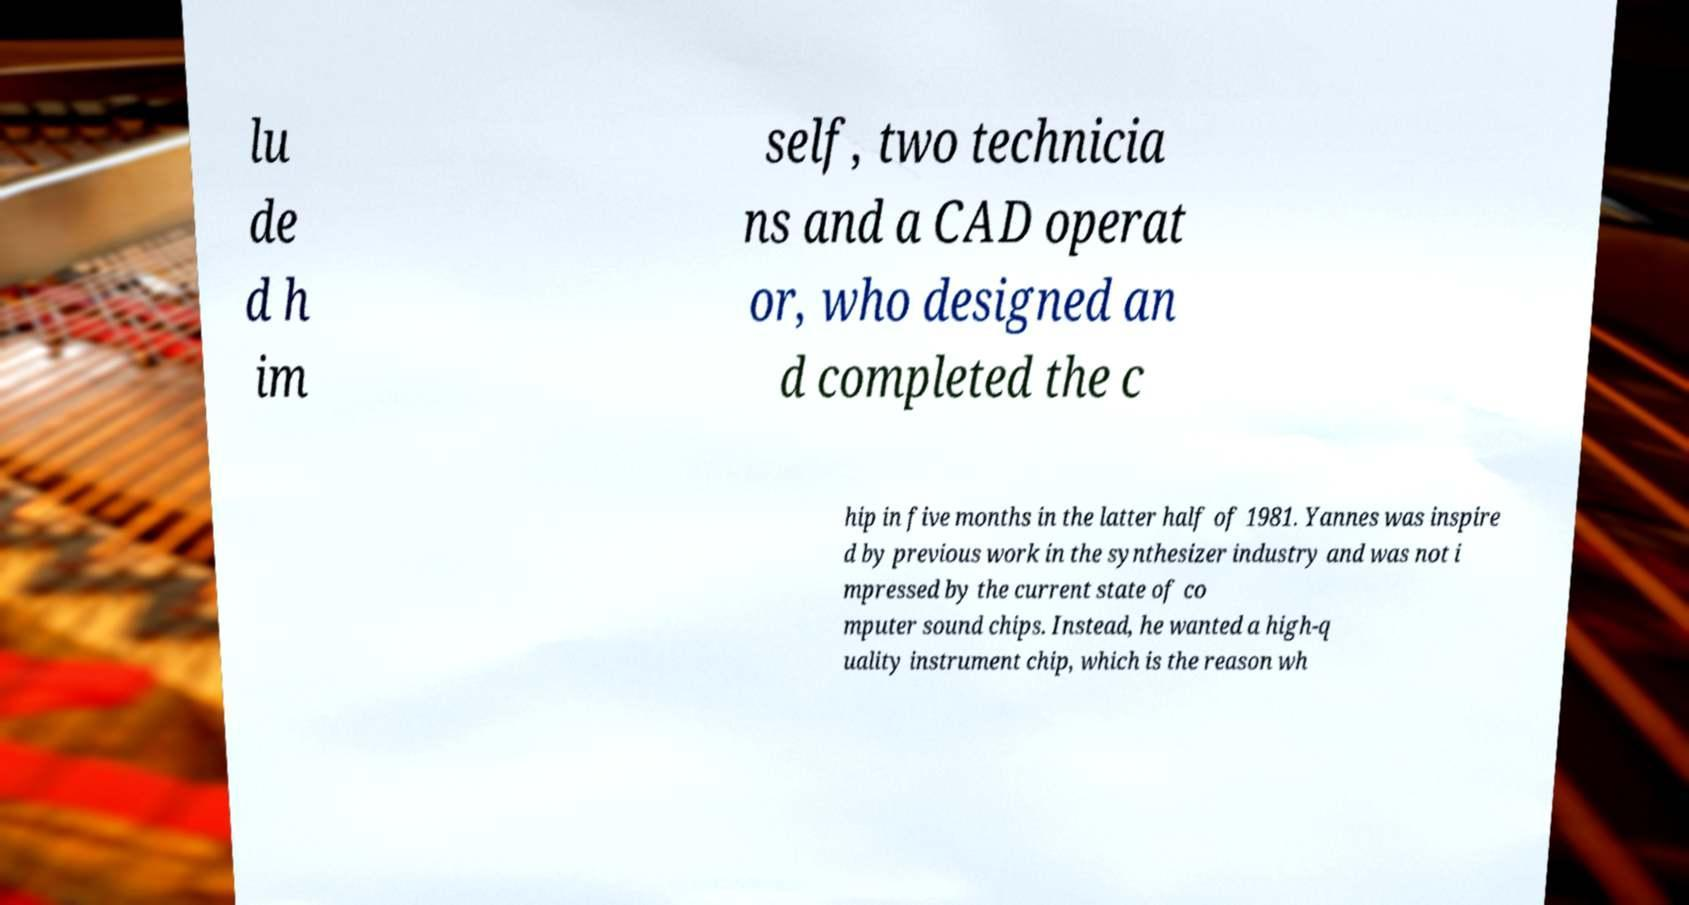Can you read and provide the text displayed in the image?This photo seems to have some interesting text. Can you extract and type it out for me? lu de d h im self, two technicia ns and a CAD operat or, who designed an d completed the c hip in five months in the latter half of 1981. Yannes was inspire d by previous work in the synthesizer industry and was not i mpressed by the current state of co mputer sound chips. Instead, he wanted a high-q uality instrument chip, which is the reason wh 